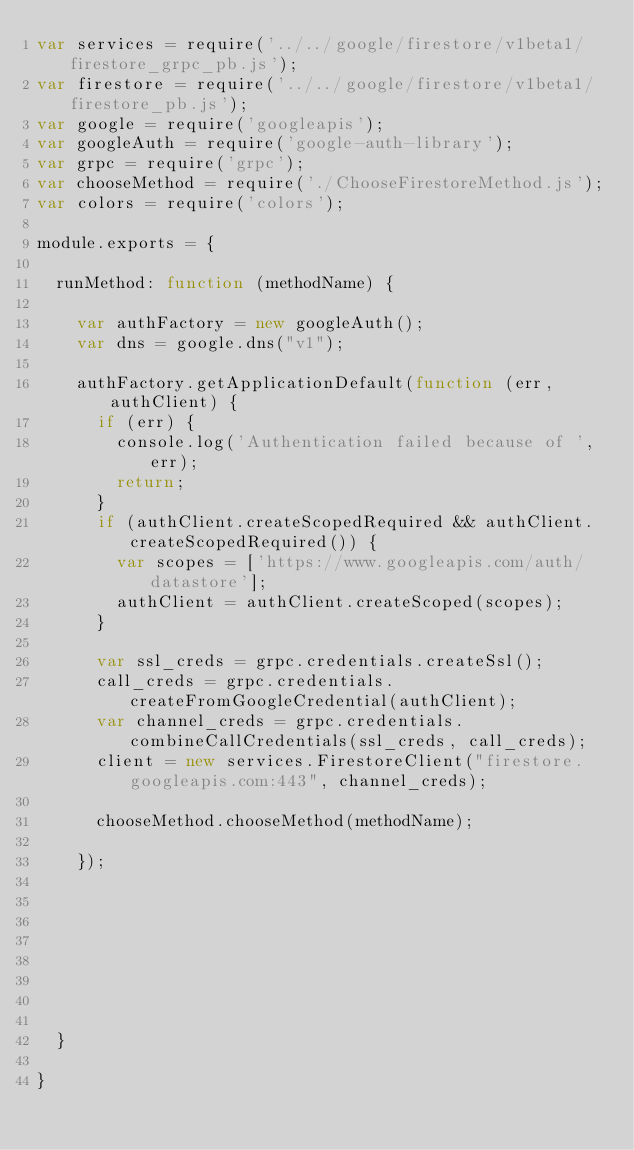Convert code to text. <code><loc_0><loc_0><loc_500><loc_500><_JavaScript_>var services = require('../../google/firestore/v1beta1/firestore_grpc_pb.js');
var firestore = require('../../google/firestore/v1beta1/firestore_pb.js');
var google = require('googleapis');
var googleAuth = require('google-auth-library');
var grpc = require('grpc');
var chooseMethod = require('./ChooseFirestoreMethod.js');
var colors = require('colors');

module.exports = {

  runMethod: function (methodName) {

    var authFactory = new googleAuth();
    var dns = google.dns("v1");

    authFactory.getApplicationDefault(function (err, authClient) {
      if (err) {
        console.log('Authentication failed because of ', err);
        return;
      }
      if (authClient.createScopedRequired && authClient.createScopedRequired()) {
        var scopes = ['https://www.googleapis.com/auth/datastore'];
        authClient = authClient.createScoped(scopes);
      }

      var ssl_creds = grpc.credentials.createSsl();
      call_creds = grpc.credentials.createFromGoogleCredential(authClient);
      var channel_creds = grpc.credentials.combineCallCredentials(ssl_creds, call_creds);
      client = new services.FirestoreClient("firestore.googleapis.com:443", channel_creds);

      chooseMethod.chooseMethod(methodName);

    });








  }

}
</code> 